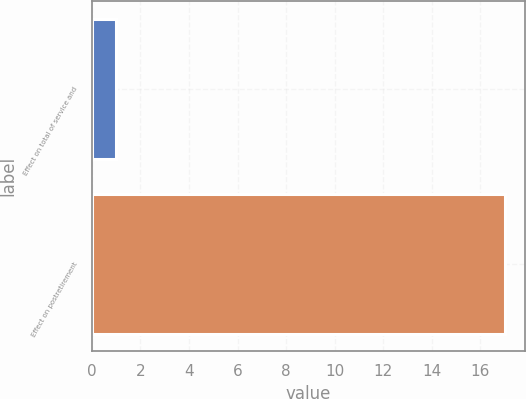Convert chart to OTSL. <chart><loc_0><loc_0><loc_500><loc_500><bar_chart><fcel>Effect on total of service and<fcel>Effect on postretirement<nl><fcel>1<fcel>17<nl></chart> 